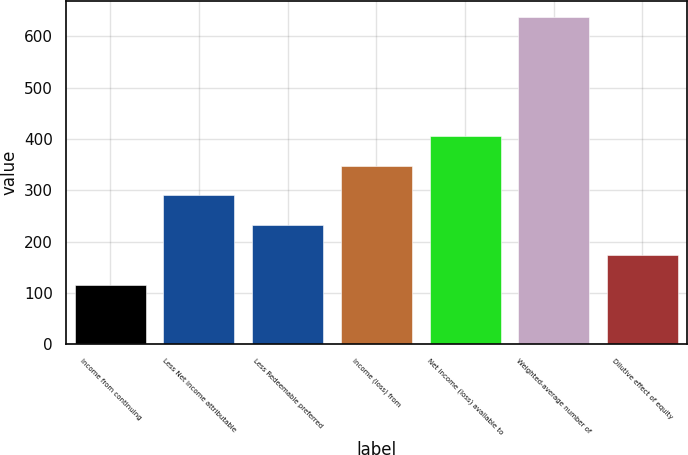Convert chart. <chart><loc_0><loc_0><loc_500><loc_500><bar_chart><fcel>Income from continuing<fcel>Less Net income attributable<fcel>Less Redeemable preferred<fcel>Income (loss) from<fcel>Net income (loss) available to<fcel>Weighted-average number of<fcel>Dilutive effect of equity<nl><fcel>116.14<fcel>289.99<fcel>232.04<fcel>347.94<fcel>405.89<fcel>637.69<fcel>174.09<nl></chart> 